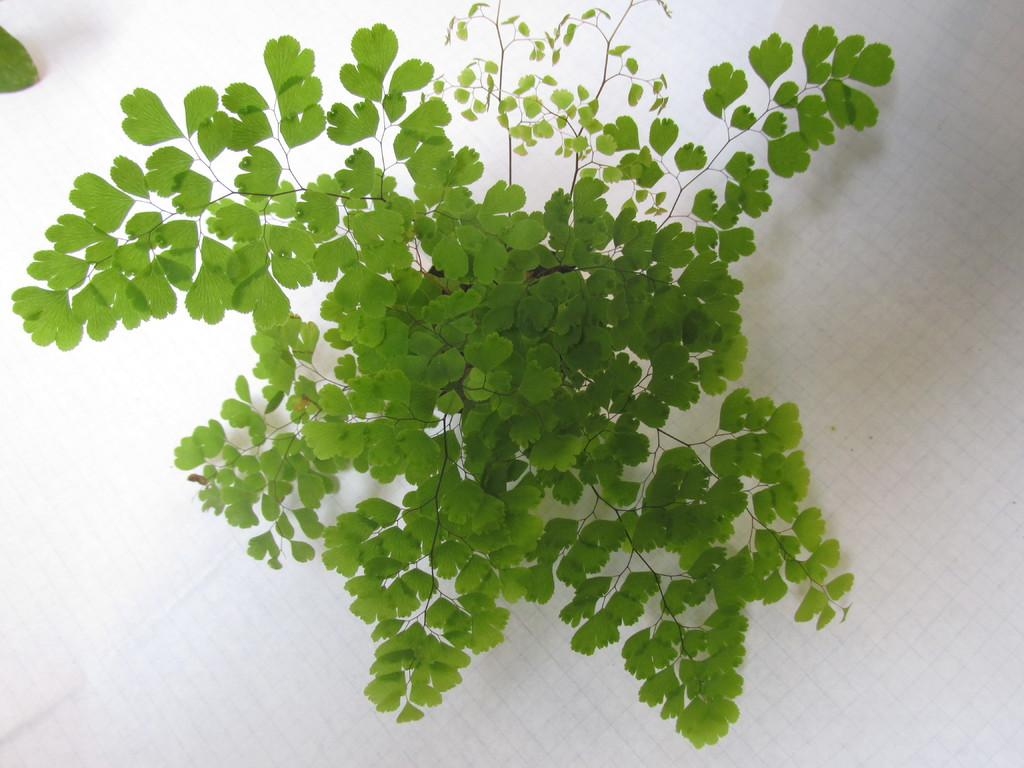What is the main subject of the image? There is a plant in the image. What is the color of the surface the plant is on? The plant is on a white surface. Can you describe any specific features of the plant? There is a leaf visible in the top left corner of the image. What type of dress is the plant wearing in the image? There is no dress present in the image, as the subject is a plant. 